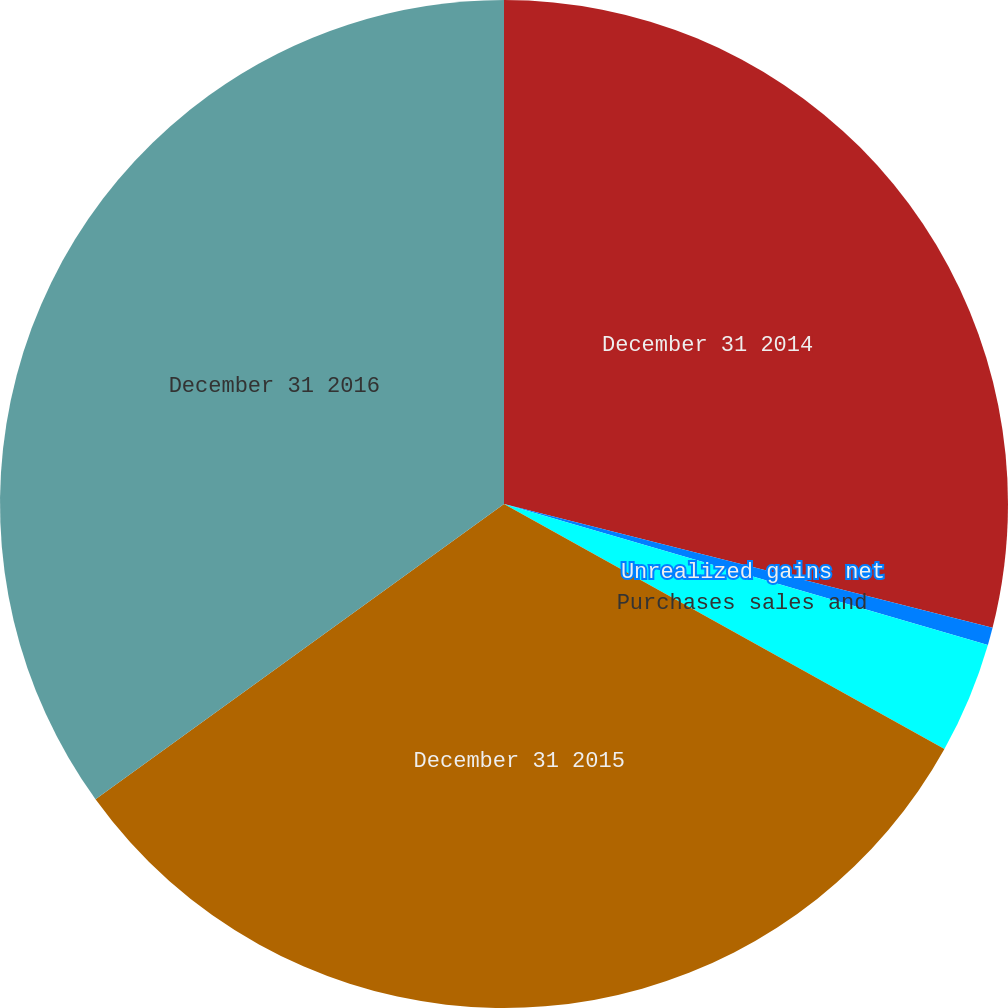Convert chart to OTSL. <chart><loc_0><loc_0><loc_500><loc_500><pie_chart><fcel>December 31 2014<fcel>Unrealized gains net<fcel>Purchases sales and<fcel>December 31 2015<fcel>December 31 2016<nl><fcel>28.95%<fcel>0.56%<fcel>3.57%<fcel>31.96%<fcel>34.96%<nl></chart> 